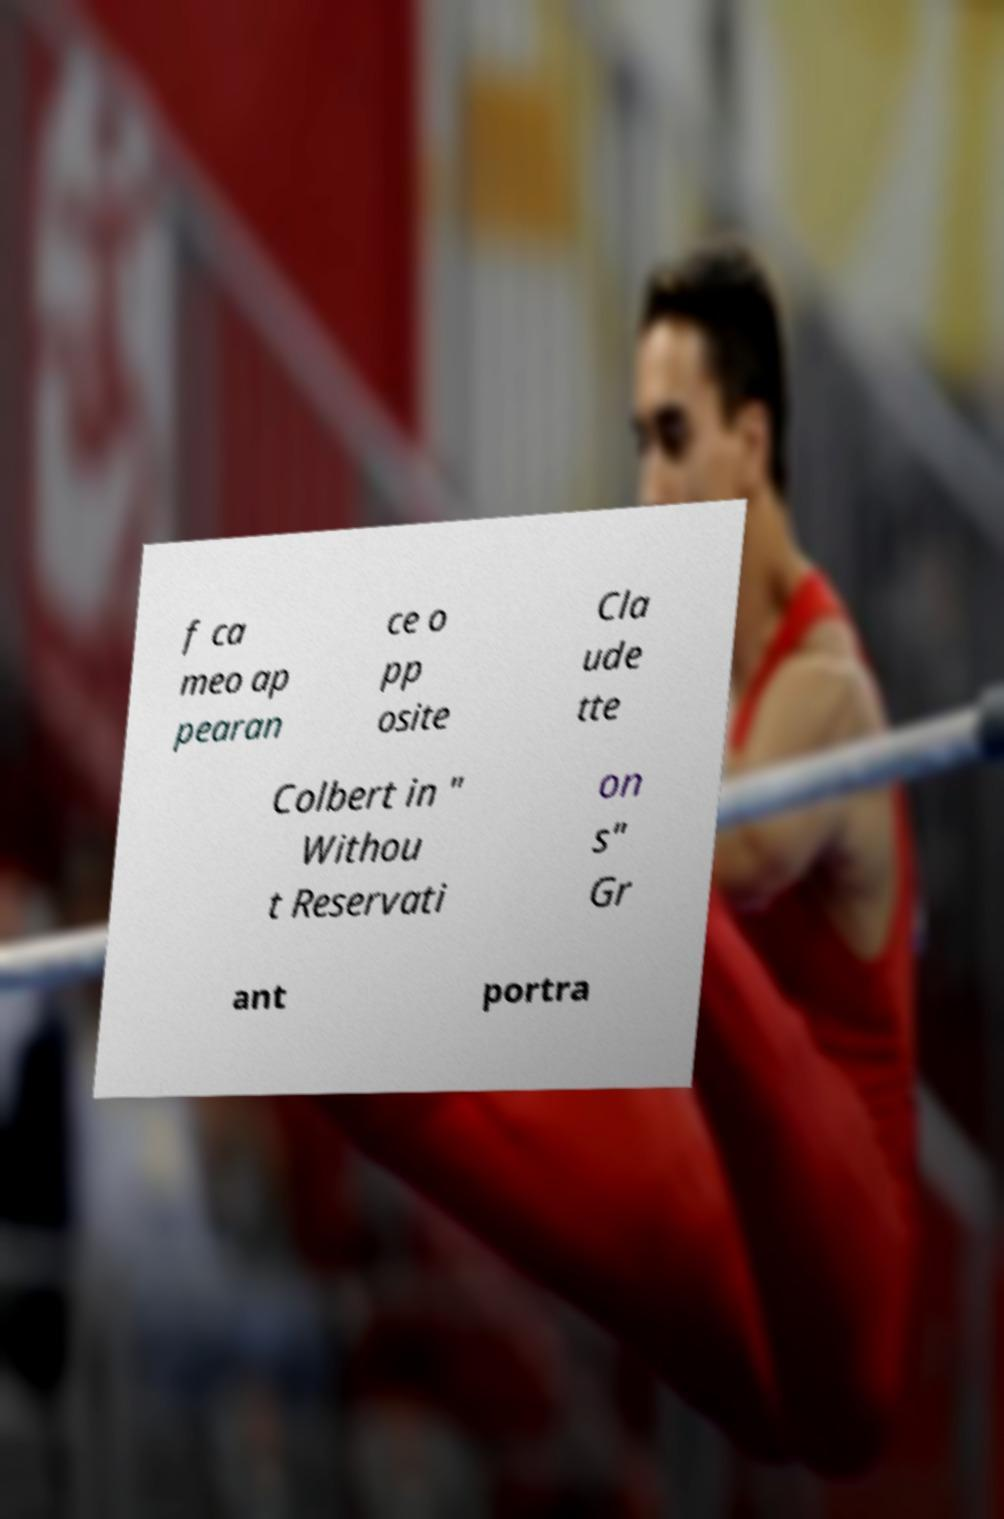Could you assist in decoding the text presented in this image and type it out clearly? f ca meo ap pearan ce o pp osite Cla ude tte Colbert in " Withou t Reservati on s" Gr ant portra 